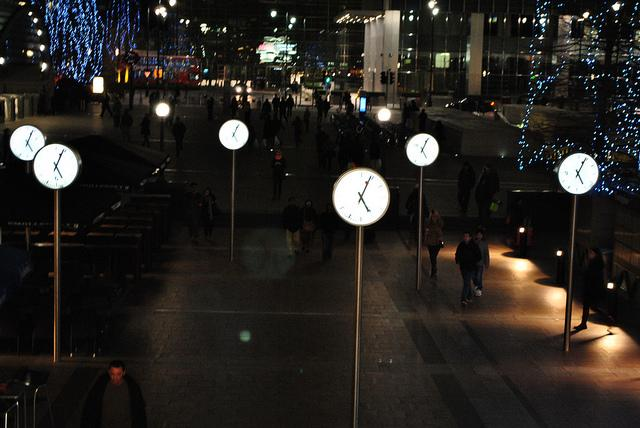Why are there blue lights on the trees?

Choices:
A) for racing
B) for climbing
C) for holiday
D) to signal for holiday 